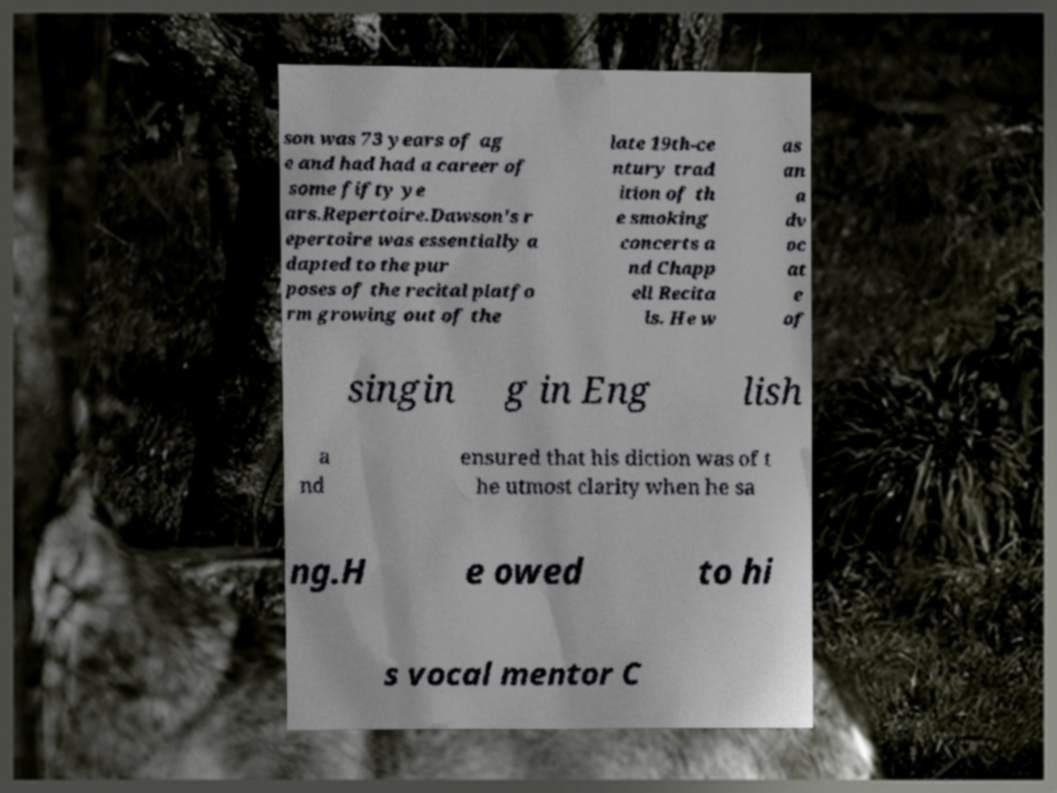Please read and relay the text visible in this image. What does it say? son was 73 years of ag e and had had a career of some fifty ye ars.Repertoire.Dawson's r epertoire was essentially a dapted to the pur poses of the recital platfo rm growing out of the late 19th-ce ntury trad ition of th e smoking concerts a nd Chapp ell Recita ls. He w as an a dv oc at e of singin g in Eng lish a nd ensured that his diction was of t he utmost clarity when he sa ng.H e owed to hi s vocal mentor C 